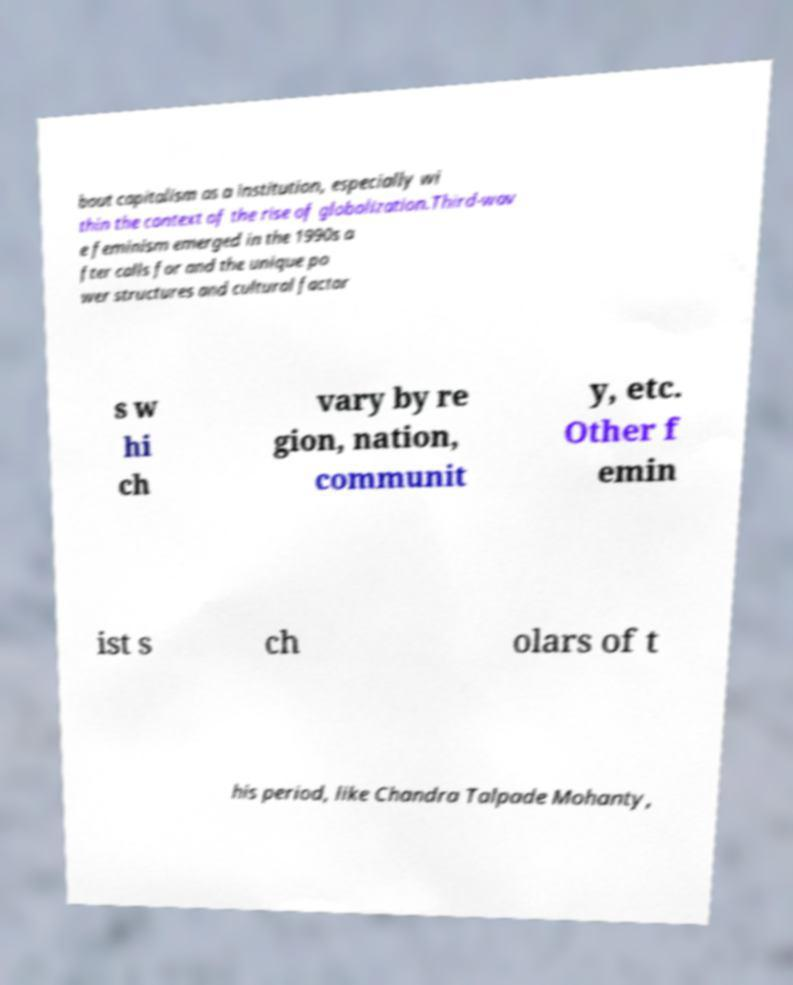There's text embedded in this image that I need extracted. Can you transcribe it verbatim? bout capitalism as a institution, especially wi thin the context of the rise of globalization.Third-wav e feminism emerged in the 1990s a fter calls for and the unique po wer structures and cultural factor s w hi ch vary by re gion, nation, communit y, etc. Other f emin ist s ch olars of t his period, like Chandra Talpade Mohanty, 